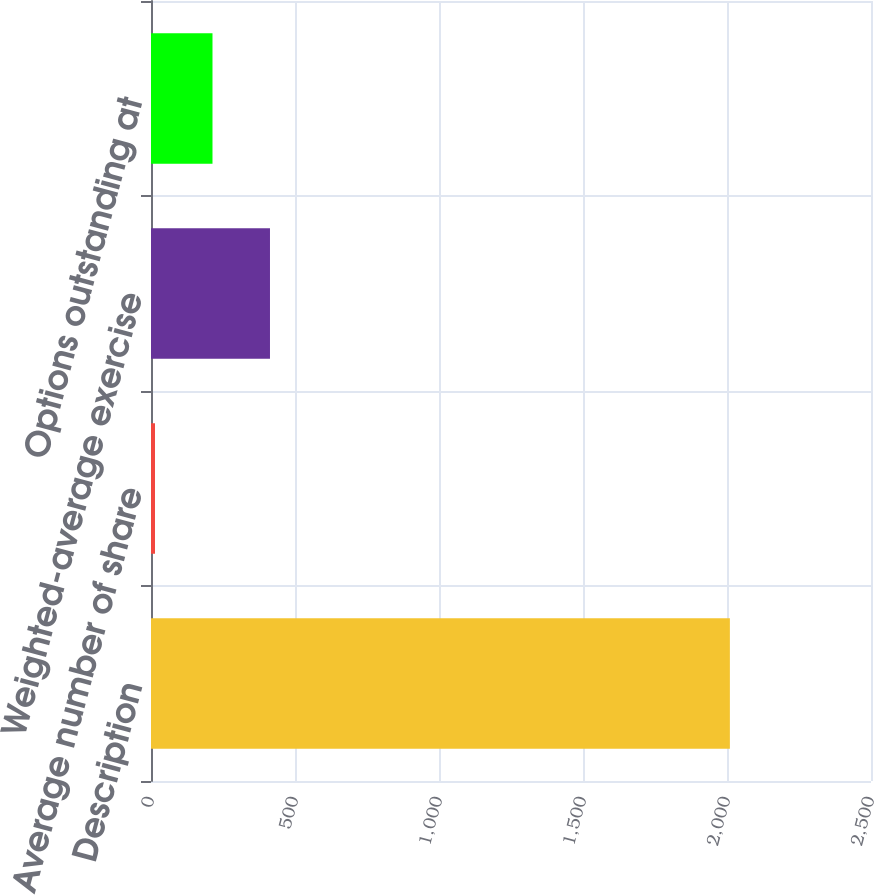Convert chart to OTSL. <chart><loc_0><loc_0><loc_500><loc_500><bar_chart><fcel>Description<fcel>Average number of share<fcel>Weighted-average exercise<fcel>Options outstanding at<nl><fcel>2010<fcel>13.9<fcel>413.12<fcel>213.51<nl></chart> 